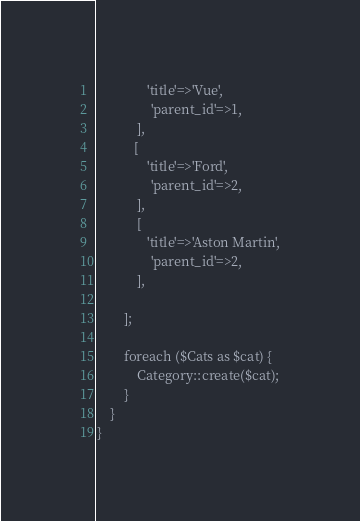<code> <loc_0><loc_0><loc_500><loc_500><_PHP_>               'title'=>'Vue',
                'parent_id'=>1,
            ],
           [
               'title'=>'Ford',
                'parent_id'=>2,
            ],
            [
               'title'=>'Aston Martin',
                'parent_id'=>2,
            ],

        ]; 

        foreach ($Cats as $cat) {
            Category::create($cat);
        }
    }
}
</code> 